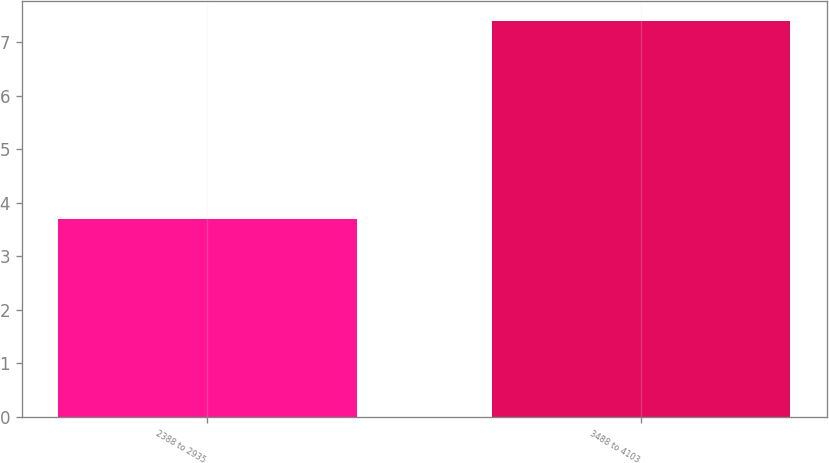Convert chart to OTSL. <chart><loc_0><loc_0><loc_500><loc_500><bar_chart><fcel>2388 to 2935<fcel>3488 to 4103<nl><fcel>3.7<fcel>7.4<nl></chart> 